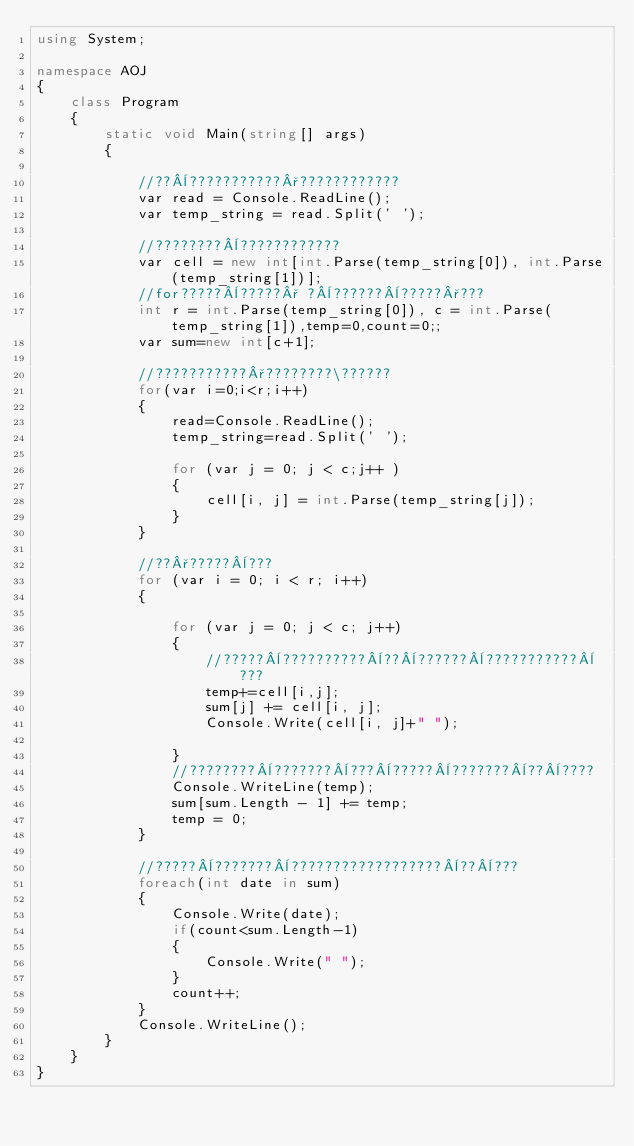Convert code to text. <code><loc_0><loc_0><loc_500><loc_500><_C#_>using System;

namespace AOJ
{
    class Program
    {
        static void Main(string[] args)
        {
          
            //??¨???????????°????????????
            var read = Console.ReadLine();
            var temp_string = read.Split(' ');

            //????????¨????????????
            var cell = new int[int.Parse(temp_string[0]), int.Parse(temp_string[1])];
            //for?????¨?????° ?¨??????¨?????°???
            int r = int.Parse(temp_string[0]), c = int.Parse(temp_string[1]),temp=0,count=0;;
            var sum=new int[c+1];

            //???????????°????????\??????
            for(var i=0;i<r;i++)
            {
                read=Console.ReadLine();
                temp_string=read.Split(' ');

                for (var j = 0; j < c;j++ )
                {
                    cell[i, j] = int.Parse(temp_string[j]);
                }
            }

            //??°?????¨???
            for (var i = 0; i < r; i++)
            {

                for (var j = 0; j < c; j++)
                {
                    //?????¨??????????¨??¨??????¨???????????¨???
                    temp+=cell[i,j];
                    sum[j] += cell[i, j];
                    Console.Write(cell[i, j]+" ");

                }
                //????????¨???????¨???¨?????¨???????¨??¨????
                Console.WriteLine(temp);
                sum[sum.Length - 1] += temp;
                temp = 0;
            }

            //?????¨???????¨??????????????????¨??¨???
            foreach(int date in sum)
            {   
                Console.Write(date);
                if(count<sum.Length-1)
                {
                    Console.Write(" ");
                }
                count++;
            }
            Console.WriteLine();
        }
    }
}</code> 